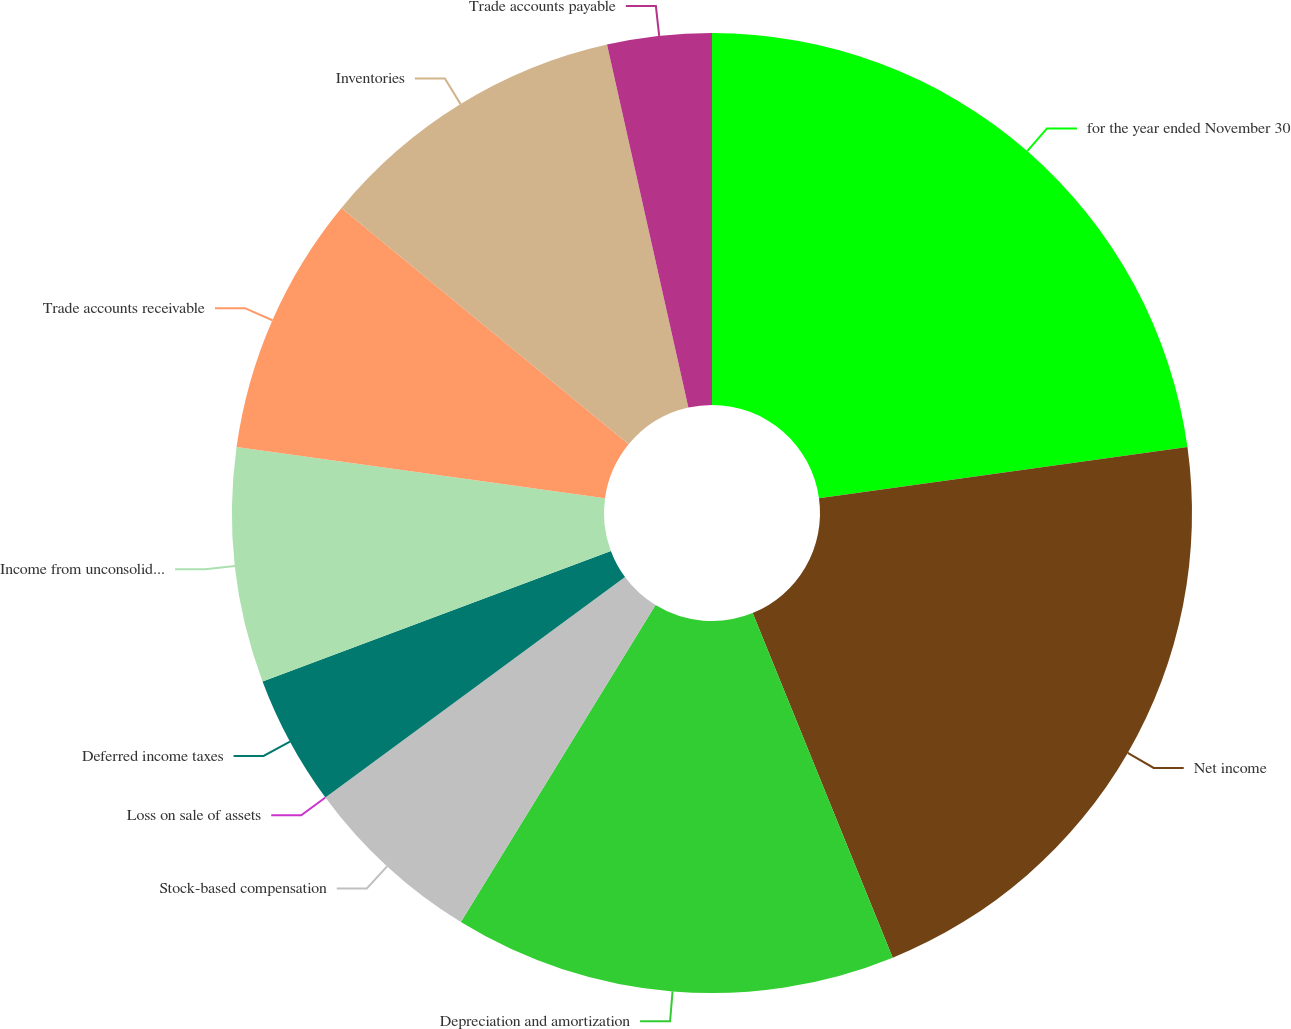<chart> <loc_0><loc_0><loc_500><loc_500><pie_chart><fcel>for the year ended November 30<fcel>Net income<fcel>Depreciation and amortization<fcel>Stock-based compensation<fcel>Loss on sale of assets<fcel>Deferred income taxes<fcel>Income from unconsolidated<fcel>Trade accounts receivable<fcel>Inventories<fcel>Trade accounts payable<nl><fcel>22.81%<fcel>21.05%<fcel>14.91%<fcel>6.14%<fcel>0.0%<fcel>4.39%<fcel>7.9%<fcel>8.77%<fcel>10.53%<fcel>3.51%<nl></chart> 